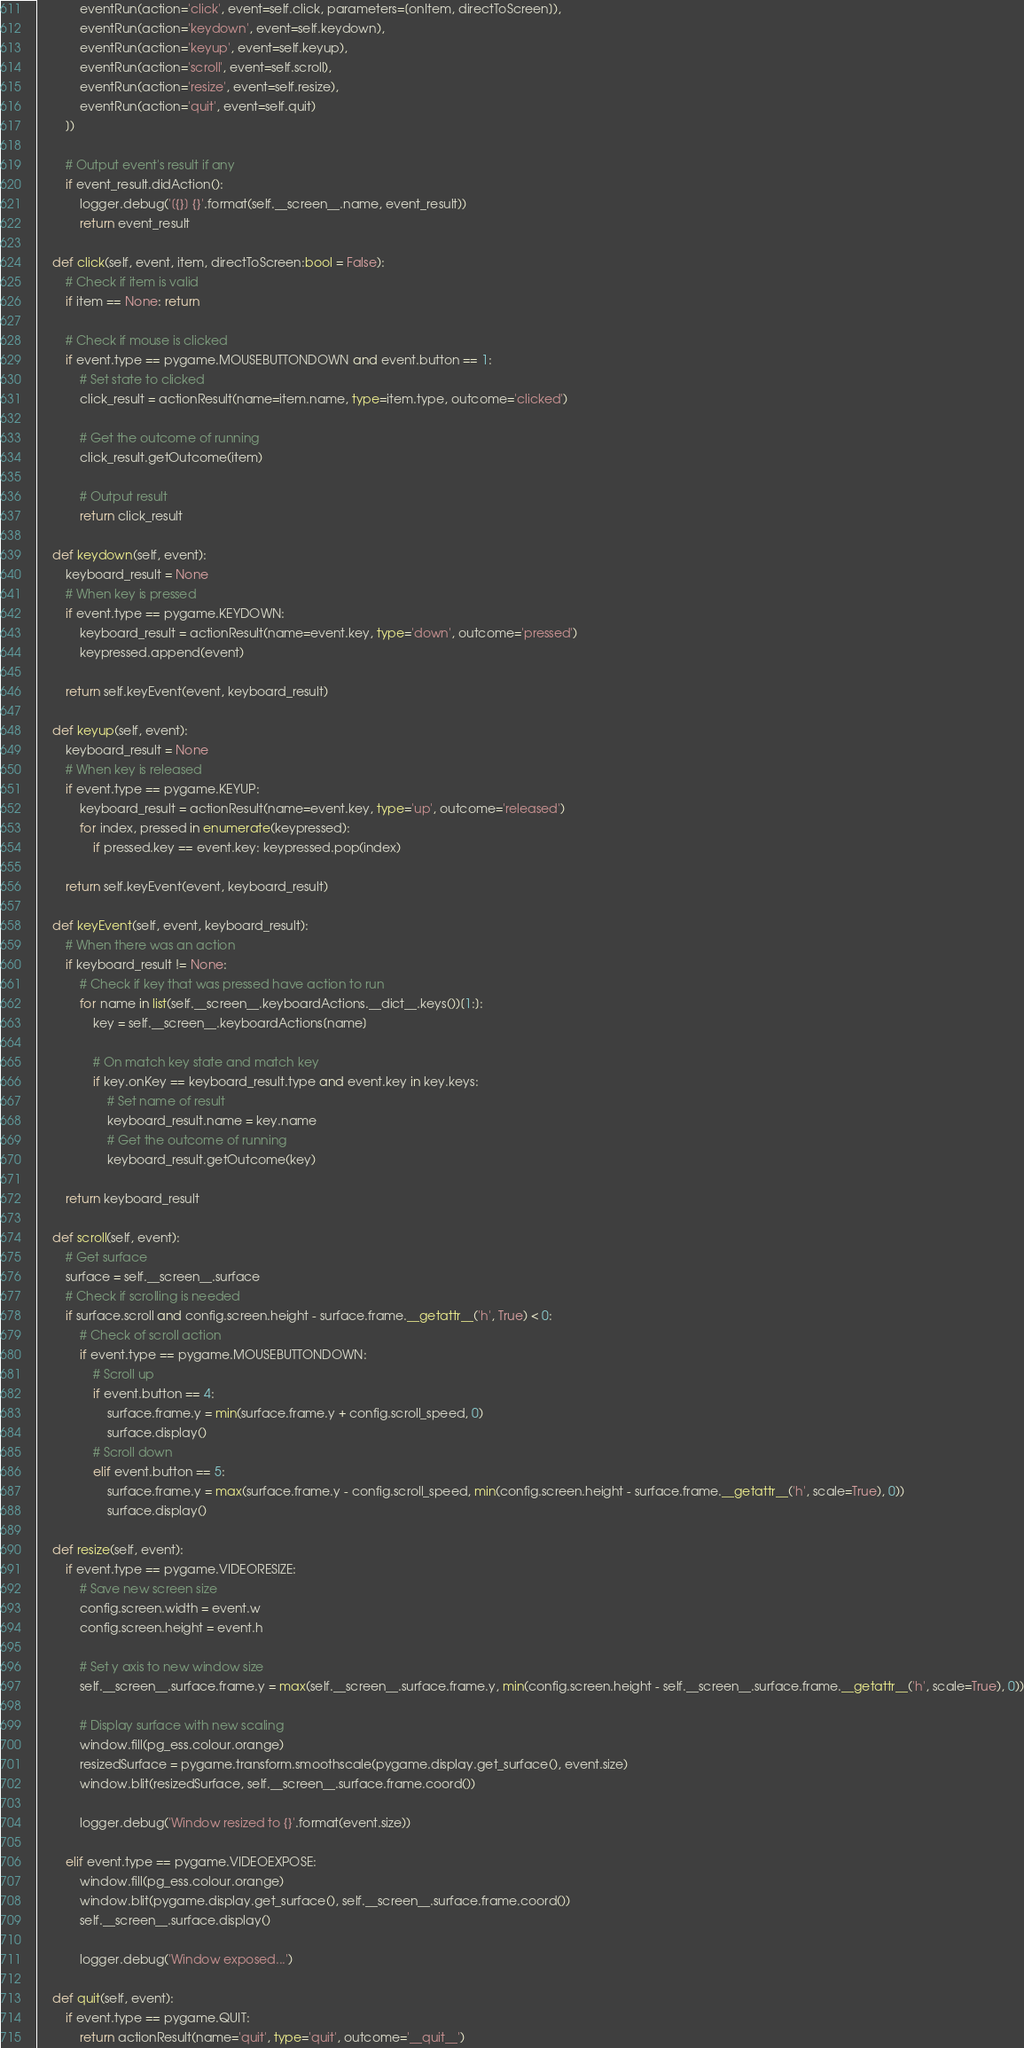Convert code to text. <code><loc_0><loc_0><loc_500><loc_500><_Python_>            eventRun(action='click', event=self.click, parameters=[onItem, directToScreen]),
            eventRun(action='keydown', event=self.keydown),
            eventRun(action='keyup', event=self.keyup),
            eventRun(action='scroll', event=self.scroll),
            eventRun(action='resize', event=self.resize),
            eventRun(action='quit', event=self.quit)
        ])
        
        # Output event's result if any
        if event_result.didAction(): 
            logger.debug('[{}] {}'.format(self.__screen__.name, event_result))
            return event_result

    def click(self, event, item, directToScreen:bool = False):
        # Check if item is valid
        if item == None: return

        # Check if mouse is clicked
        if event.type == pygame.MOUSEBUTTONDOWN and event.button == 1:
            # Set state to clicked
            click_result = actionResult(name=item.name, type=item.type, outcome='clicked')
            
            # Get the outcome of running
            click_result.getOutcome(item)

            # Output result
            return click_result

    def keydown(self, event):
        keyboard_result = None
        # When key is pressed
        if event.type == pygame.KEYDOWN:
            keyboard_result = actionResult(name=event.key, type='down', outcome='pressed')
            keypressed.append(event)

        return self.keyEvent(event, keyboard_result)
        
    def keyup(self, event):
        keyboard_result = None
        # When key is released
        if event.type == pygame.KEYUP:
            keyboard_result = actionResult(name=event.key, type='up', outcome='released')
            for index, pressed in enumerate(keypressed):
                if pressed.key == event.key: keypressed.pop(index)
        
        return self.keyEvent(event, keyboard_result)

    def keyEvent(self, event, keyboard_result):
        # When there was an action
        if keyboard_result != None:
            # Check if key that was pressed have action to run
            for name in list(self.__screen__.keyboardActions.__dict__.keys())[1:]:
                key = self.__screen__.keyboardActions[name]

                # On match key state and match key
                if key.onKey == keyboard_result.type and event.key in key.keys:
                    # Set name of result
                    keyboard_result.name = key.name
                    # Get the outcome of running
                    keyboard_result.getOutcome(key) 
            
        return keyboard_result

    def scroll(self, event):
        # Get surface
        surface = self.__screen__.surface
        # Check if scrolling is needed
        if surface.scroll and config.screen.height - surface.frame.__getattr__('h', True) < 0:
            # Check of scroll action
            if event.type == pygame.MOUSEBUTTONDOWN:
                # Scroll up
                if event.button == 4:
                    surface.frame.y = min(surface.frame.y + config.scroll_speed, 0) 
                    surface.display()
                # Scroll down
                elif event.button == 5:
                    surface.frame.y = max(surface.frame.y - config.scroll_speed, min(config.screen.height - surface.frame.__getattr__('h', scale=True), 0))
                    surface.display()

    def resize(self, event):
        if event.type == pygame.VIDEORESIZE:
            # Save new screen size
            config.screen.width = event.w
            config.screen.height = event.h

            # Set y axis to new window size
            self.__screen__.surface.frame.y = max(self.__screen__.surface.frame.y, min(config.screen.height - self.__screen__.surface.frame.__getattr__('h', scale=True), 0))
            
            # Display surface with new scaling 
            window.fill(pg_ess.colour.orange)
            resizedSurface = pygame.transform.smoothscale(pygame.display.get_surface(), event.size)
            window.blit(resizedSurface, self.__screen__.surface.frame.coord())
            
            logger.debug('Window resized to {}'.format(event.size))
        
        elif event.type == pygame.VIDEOEXPOSE:  
            window.fill(pg_ess.colour.orange)
            window.blit(pygame.display.get_surface(), self.__screen__.surface.frame.coord())
            self.__screen__.surface.display() 

            logger.debug('Window exposed...')

    def quit(self, event):
        if event.type == pygame.QUIT: 
            return actionResult(name='quit', type='quit', outcome='__quit__')</code> 